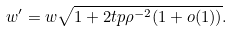Convert formula to latex. <formula><loc_0><loc_0><loc_500><loc_500>w ^ { \prime } = w \sqrt { 1 + 2 t p \rho ^ { - 2 } ( 1 + o ( 1 ) ) } .</formula> 